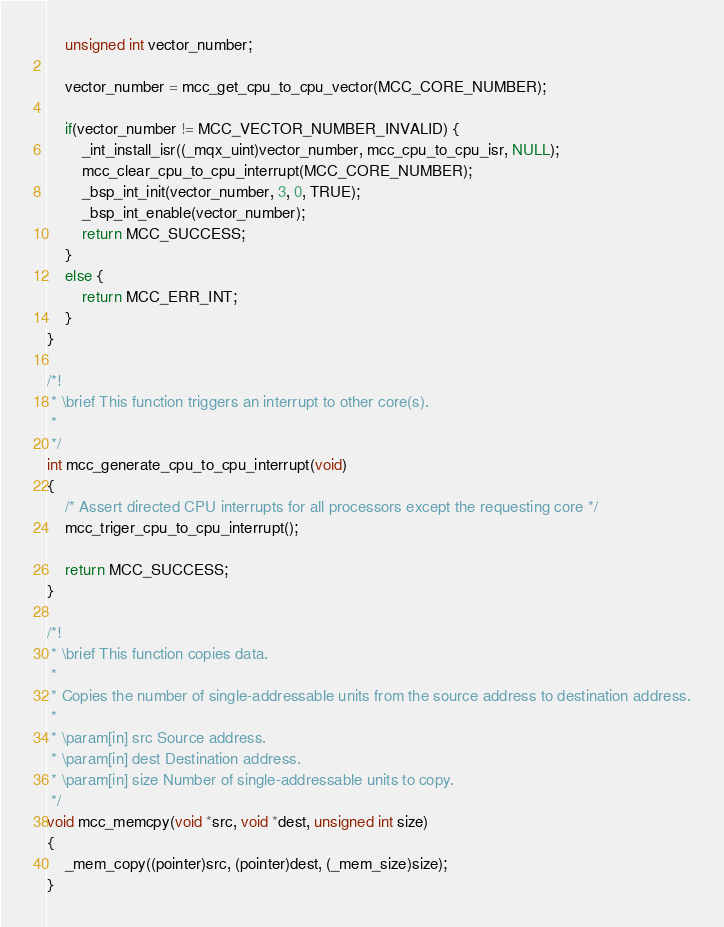Convert code to text. <code><loc_0><loc_0><loc_500><loc_500><_C_>    unsigned int vector_number;

    vector_number = mcc_get_cpu_to_cpu_vector(MCC_CORE_NUMBER);

    if(vector_number != MCC_VECTOR_NUMBER_INVALID) {
        _int_install_isr((_mqx_uint)vector_number, mcc_cpu_to_cpu_isr, NULL);
        mcc_clear_cpu_to_cpu_interrupt(MCC_CORE_NUMBER);
        _bsp_int_init(vector_number, 3, 0, TRUE);
        _bsp_int_enable(vector_number);
        return MCC_SUCCESS;
    }
    else {
        return MCC_ERR_INT;
    }
}

/*!
 * \brief This function triggers an interrupt to other core(s).
 *
 */
int mcc_generate_cpu_to_cpu_interrupt(void)
{
    /* Assert directed CPU interrupts for all processors except the requesting core */
    mcc_triger_cpu_to_cpu_interrupt();

    return MCC_SUCCESS;
}

/*!
 * \brief This function copies data.
 *
 * Copies the number of single-addressable units from the source address to destination address.
 *
 * \param[in] src Source address.
 * \param[in] dest Destination address.
 * \param[in] size Number of single-addressable units to copy.
 */
void mcc_memcpy(void *src, void *dest, unsigned int size)
{
    _mem_copy((pointer)src, (pointer)dest, (_mem_size)size);
}

</code> 